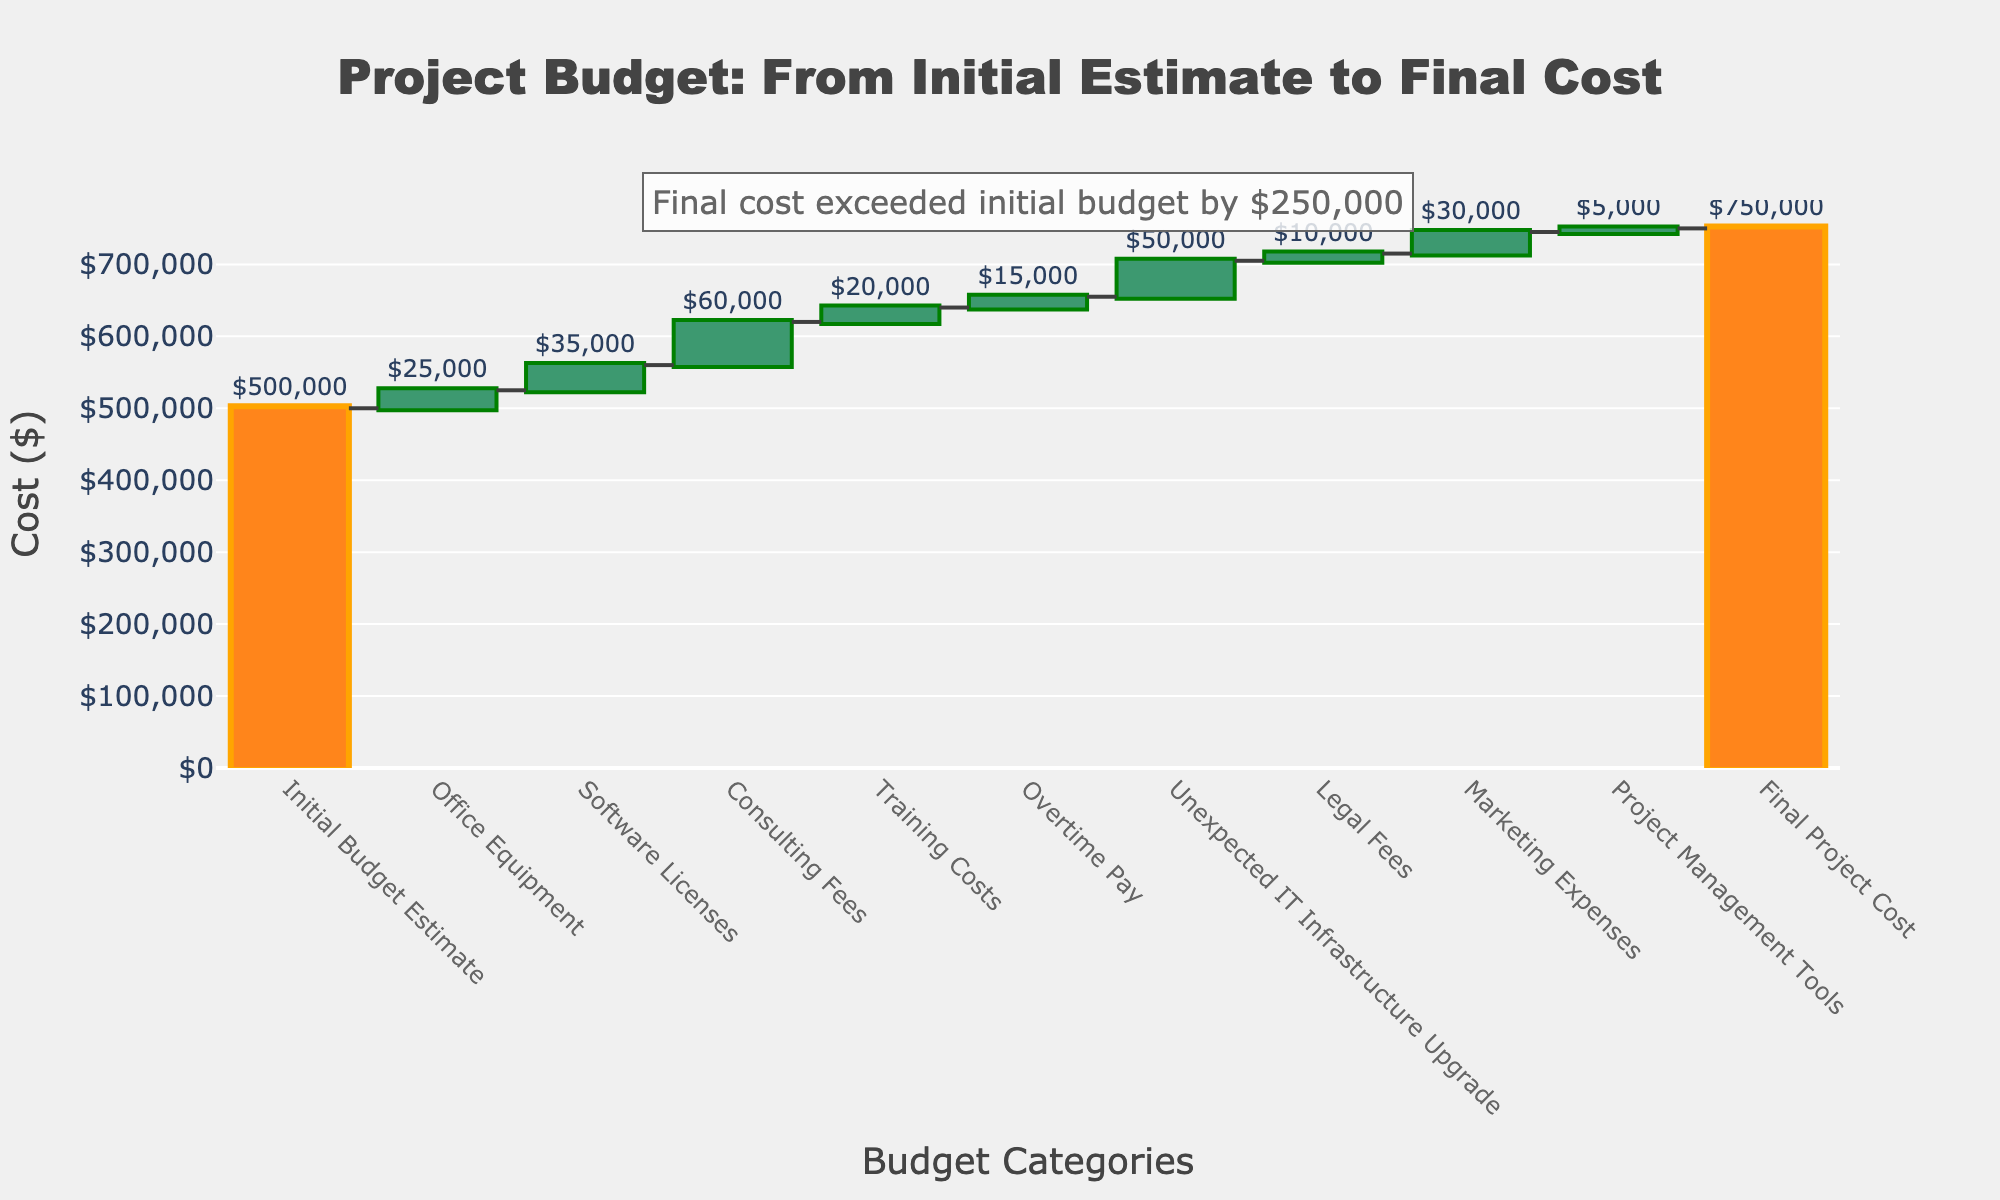What is the title of the chart? The title of the chart is located at the top and reads "Project Budget: From Initial Estimate to Final Cost."
Answer: Project Budget: From Initial Estimate to Final Cost What is the value of the "Office Equipment" category? The value for the "Office Equipment" category is displayed above its respective bar and reads "$25,000."
Answer: $25,000 How much did the "Unexpected IT Infrastructure Upgrade" contribute to the total cost? The "Unexpected IT Infrastructure Upgrade" bar shows a value of $50,000. This is the amount added to the total cost due to this category.
Answer: $50,000 What is the final project cost? The final project cost is displayed at the end of the chart as the final bar and reads "$750,000."
Answer: $750,000 Which category had the highest cost addition to the budget? By visually comparing the heights of the bars, "Consulting Fees" had the highest cost addition to the budget with a value of $60,000.
Answer: Consulting Fees What is the total of all the intermediary costs combined? Summing the intermediary values: (25,000 + 35,000 + 60,000 + 20,000 + 15,000 + 50,000 + 10,000 + 30,000 + 5,000) = 250,000. This reflects the total of the intermediary costs in the chart.
Answer: $250,000 How much greater is the final project cost compared to the initial budget estimate? The initial budget estimate is $500,000 and the final project cost is $750,000. So, the difference is 750,000 - 500,000 = $250,000.
Answer: $250,000 Did any categories contribute to reducing the overall budget? All the categories shown in the waterfall chart contribute positively to the budget, resulting in an increased final cost. None of the bars indicate a reduction.
Answer: No What is the cumulative value after accounting for "Training Costs"? The cumulative value after "Training Costs" is the sum of the initial budget and the costs up to and including "Training Costs": 500,000 (Initial) + 25,000 (Office Equipment) + 35,000 (Software Licenses) + 60,000 (Consulting Fees) + 20,000 (Training Costs) = 640,000.
Answer: $640,000 Explain how the "Final Project Cost" is calculated in this context. The "Final Project Cost" is calculated by taking the initial budget estimate of $500,000 and adding the cumulative intermediary costs: 25,000 (Office Equipment) + 35,000 (Software Licenses) + 60,000 (Consulting Fees) + 20,000 (Training Costs) + 15,000 (Overtime Pay) + 50,000 (Unexpected IT Infrastructure Upgrade) + 10,000 (Legal Fees) + 30,000 (Marketing Expenses) + 5,000 (Project Management Tools). Summing these gives an additional $250,000 added to the initial budget, resulting in the final cost of 750,000.
Answer: $750,000 